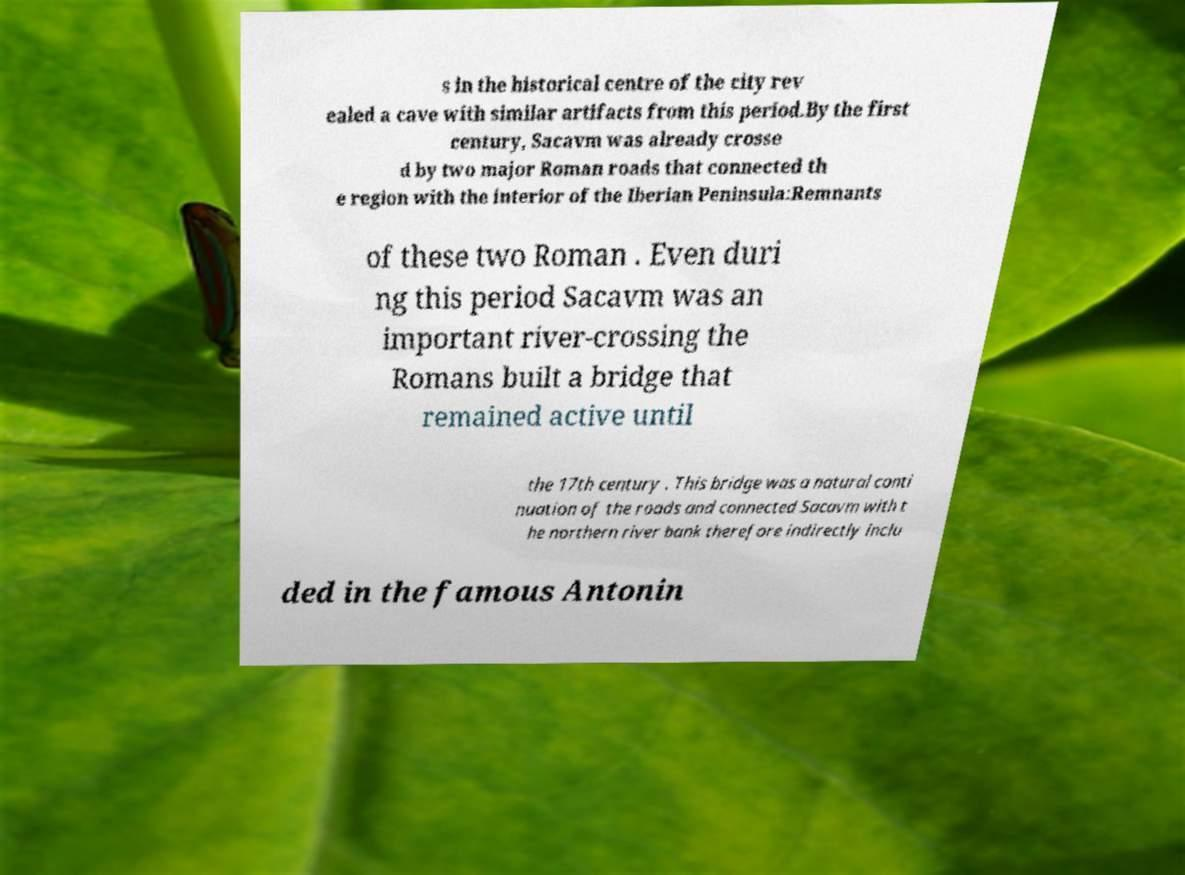For documentation purposes, I need the text within this image transcribed. Could you provide that? s in the historical centre of the city rev ealed a cave with similar artifacts from this period.By the first century, Sacavm was already crosse d by two major Roman roads that connected th e region with the interior of the Iberian Peninsula:Remnants of these two Roman . Even duri ng this period Sacavm was an important river-crossing the Romans built a bridge that remained active until the 17th century . This bridge was a natural conti nuation of the roads and connected Sacavm with t he northern river bank therefore indirectly inclu ded in the famous Antonin 